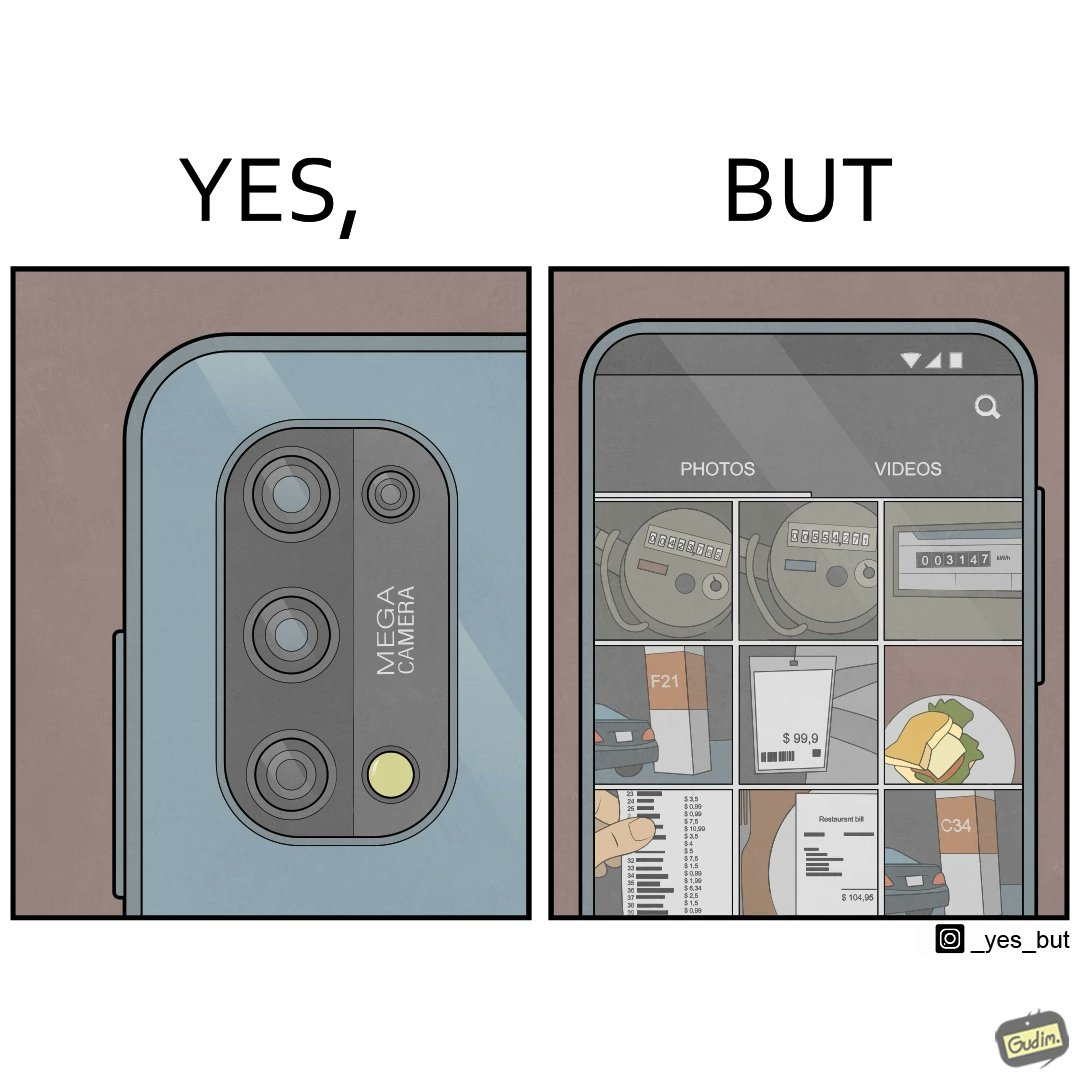Why is this image considered satirical? The irony here is that people buy phones with flashy camera systems just to click pictures of random and insignificant things. 